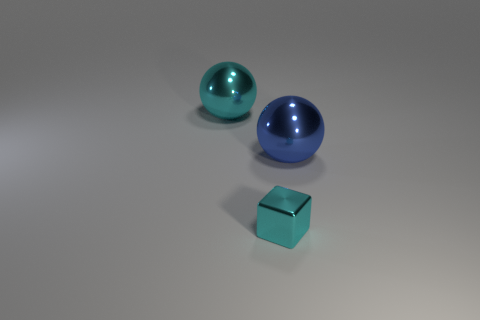Add 1 large cyan objects. How many objects exist? 4 Subtract 1 balls. How many balls are left? 1 Add 3 small shiny things. How many small shiny things are left? 4 Add 1 large purple shiny objects. How many large purple shiny objects exist? 1 Subtract 0 green spheres. How many objects are left? 3 Subtract all blocks. How many objects are left? 2 Subtract all gray spheres. Subtract all cyan cylinders. How many spheres are left? 2 Subtract all cyan cubes. How many cyan spheres are left? 1 Subtract all large red rubber cubes. Subtract all small metallic blocks. How many objects are left? 2 